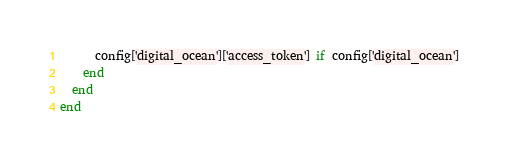Convert code to text. <code><loc_0><loc_0><loc_500><loc_500><_Ruby_>      config['digital_ocean']['access_token'] if config['digital_ocean']
    end
  end
end
</code> 